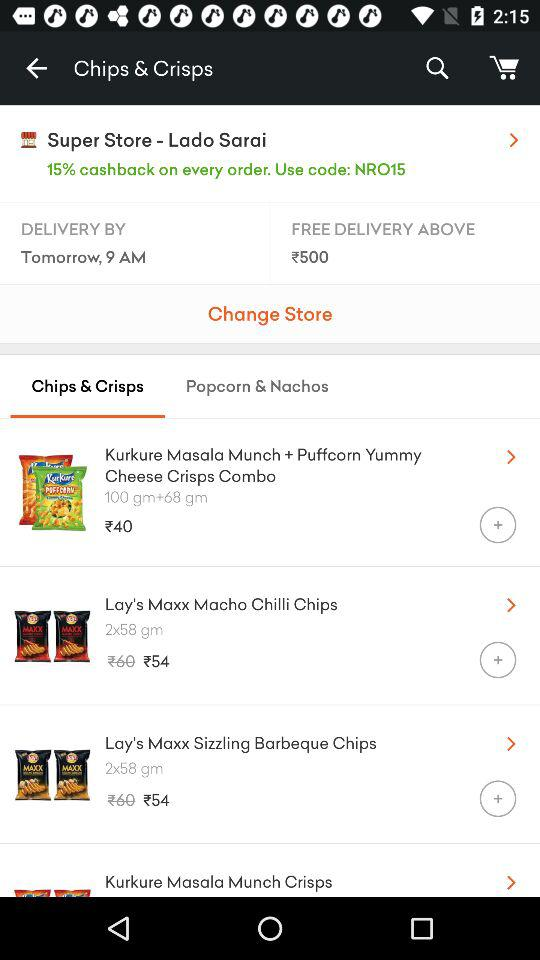Which tab is selected? The selected tab is "Chips & Crisps". 